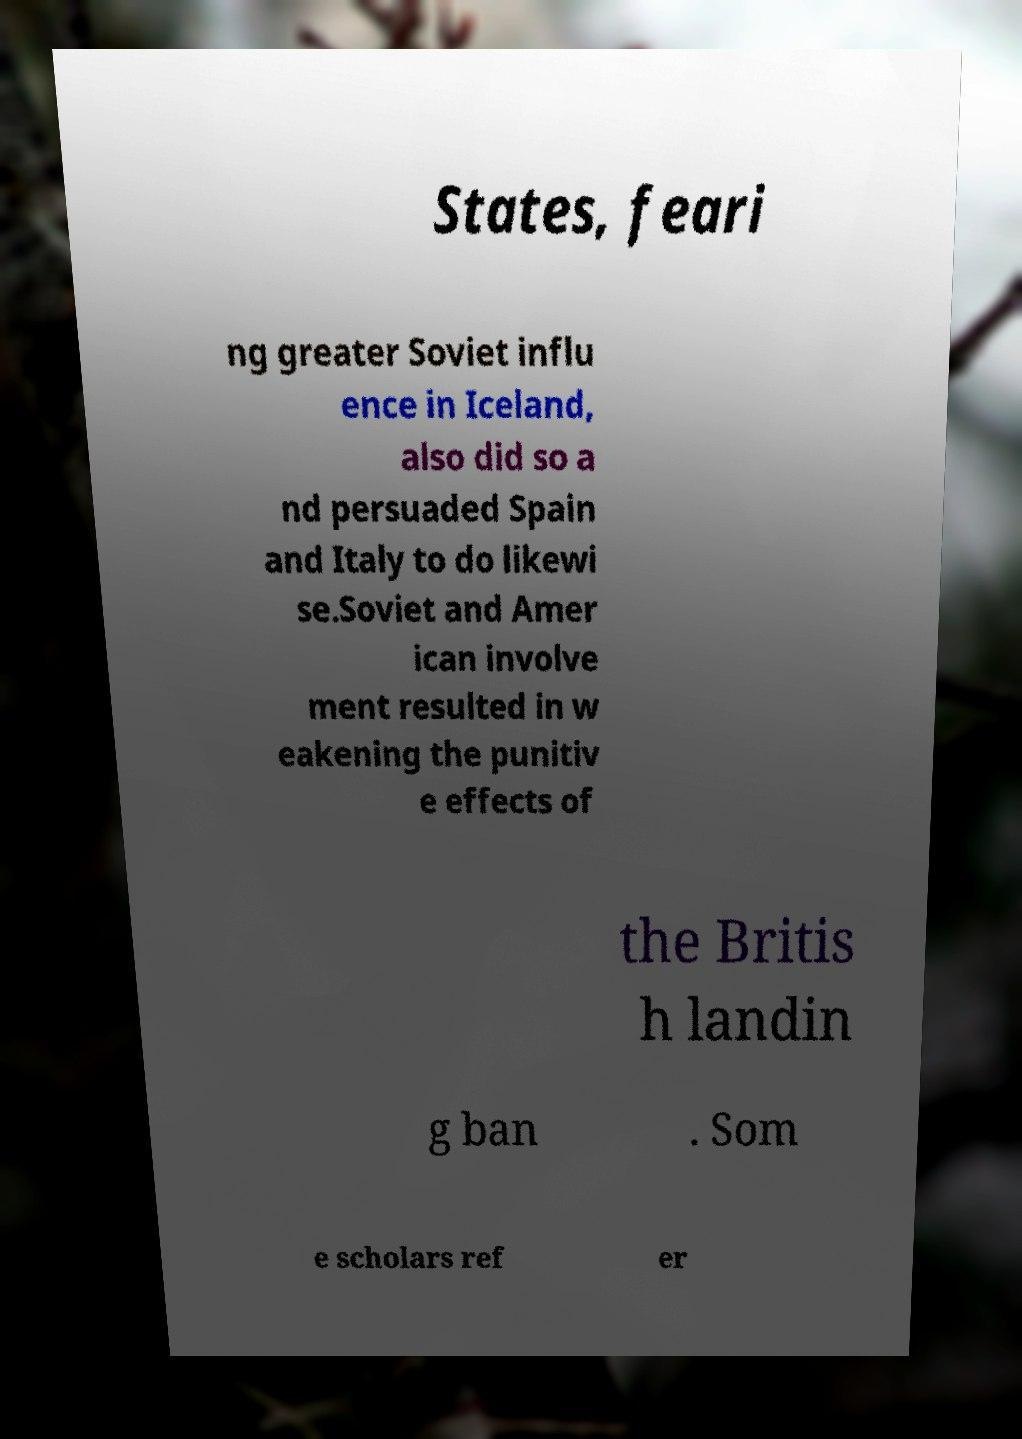Could you assist in decoding the text presented in this image and type it out clearly? States, feari ng greater Soviet influ ence in Iceland, also did so a nd persuaded Spain and Italy to do likewi se.Soviet and Amer ican involve ment resulted in w eakening the punitiv e effects of the Britis h landin g ban . Som e scholars ref er 